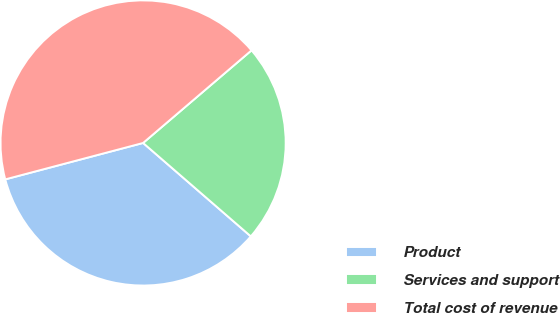<chart> <loc_0><loc_0><loc_500><loc_500><pie_chart><fcel>Product<fcel>Services and support<fcel>Total cost of revenue<nl><fcel>34.52%<fcel>22.62%<fcel>42.86%<nl></chart> 